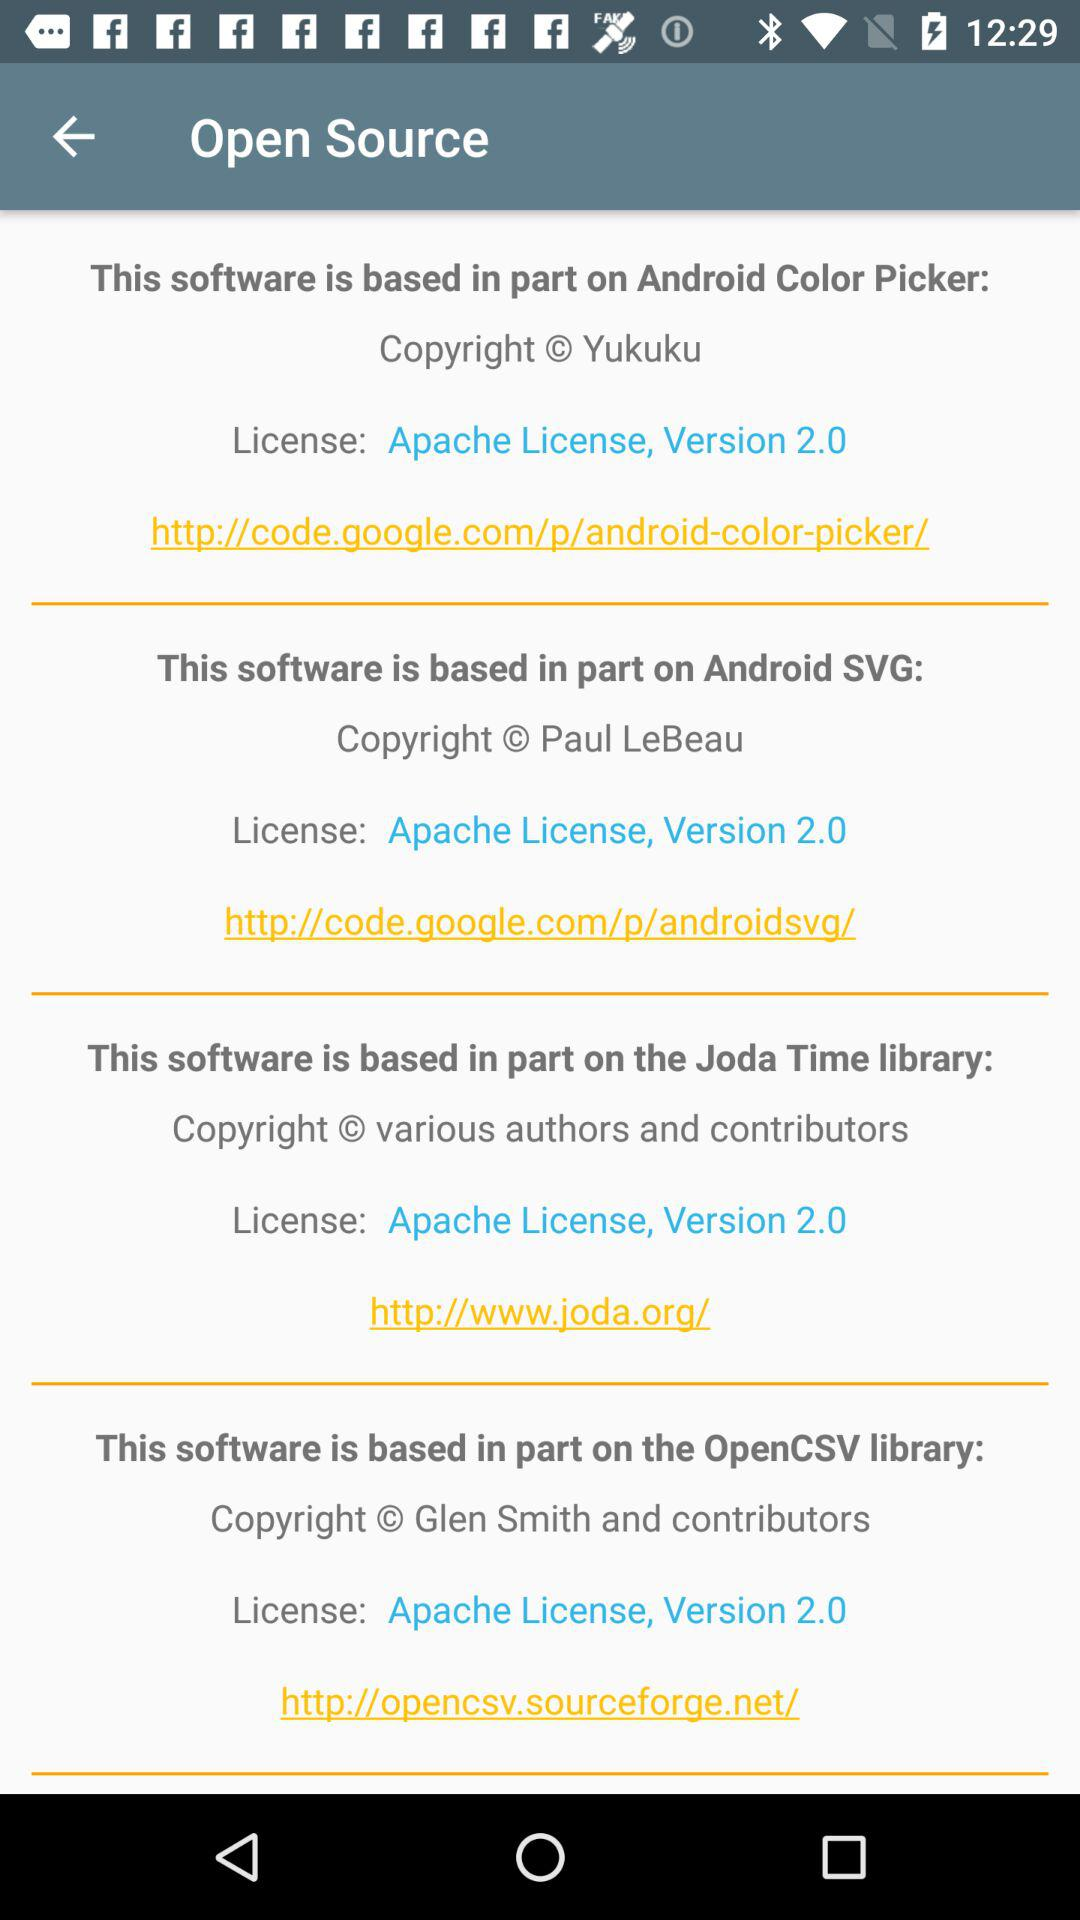Who owns the copyright for Android SVG? The copyright for Android SVG is owned by Paul LeBeau. 